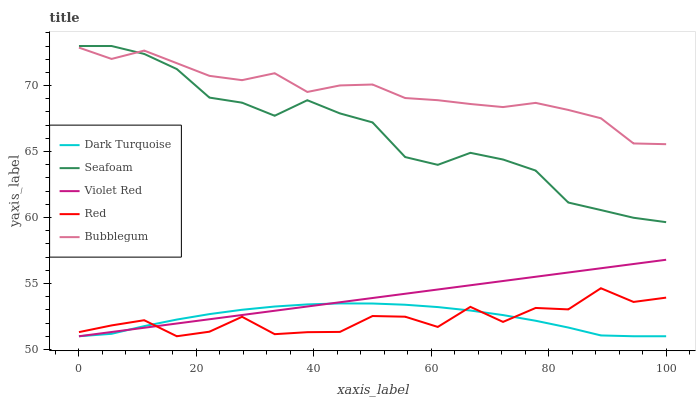Does Red have the minimum area under the curve?
Answer yes or no. Yes. Does Bubblegum have the maximum area under the curve?
Answer yes or no. Yes. Does Violet Red have the minimum area under the curve?
Answer yes or no. No. Does Violet Red have the maximum area under the curve?
Answer yes or no. No. Is Violet Red the smoothest?
Answer yes or no. Yes. Is Red the roughest?
Answer yes or no. Yes. Is Bubblegum the smoothest?
Answer yes or no. No. Is Bubblegum the roughest?
Answer yes or no. No. Does Dark Turquoise have the lowest value?
Answer yes or no. Yes. Does Bubblegum have the lowest value?
Answer yes or no. No. Does Seafoam have the highest value?
Answer yes or no. Yes. Does Violet Red have the highest value?
Answer yes or no. No. Is Red less than Seafoam?
Answer yes or no. Yes. Is Bubblegum greater than Dark Turquoise?
Answer yes or no. Yes. Does Violet Red intersect Dark Turquoise?
Answer yes or no. Yes. Is Violet Red less than Dark Turquoise?
Answer yes or no. No. Is Violet Red greater than Dark Turquoise?
Answer yes or no. No. Does Red intersect Seafoam?
Answer yes or no. No. 